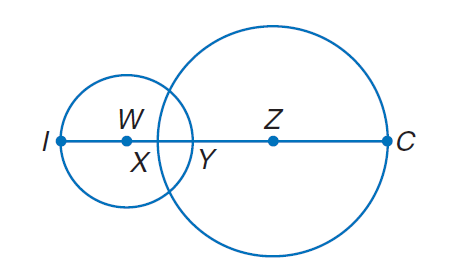Answer the mathemtical geometry problem and directly provide the correct option letter.
Question: Circle W has a radius of 4 units, \odot Z has a radius of 7 units, and X Y = 2. Find Y Z.
Choices: A: 5 B: 10 C: 15 D: 20 A 